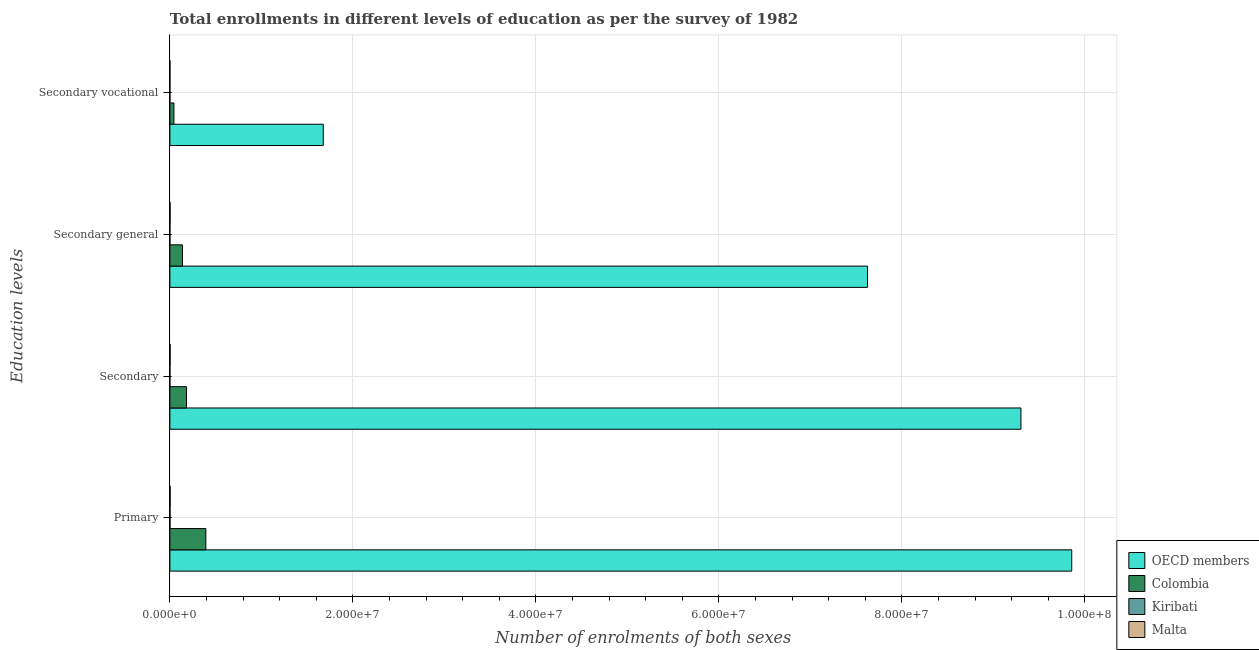How many different coloured bars are there?
Give a very brief answer. 4. Are the number of bars on each tick of the Y-axis equal?
Keep it short and to the point. Yes. How many bars are there on the 3rd tick from the top?
Your answer should be compact. 4. What is the label of the 3rd group of bars from the top?
Ensure brevity in your answer.  Secondary. What is the number of enrolments in primary education in Malta?
Give a very brief answer. 3.32e+04. Across all countries, what is the maximum number of enrolments in secondary education?
Provide a succinct answer. 9.30e+07. Across all countries, what is the minimum number of enrolments in secondary vocational education?
Make the answer very short. 946. In which country was the number of enrolments in secondary education maximum?
Ensure brevity in your answer.  OECD members. In which country was the number of enrolments in primary education minimum?
Make the answer very short. Kiribati. What is the total number of enrolments in secondary vocational education in the graph?
Make the answer very short. 1.72e+07. What is the difference between the number of enrolments in primary education in Kiribati and that in Malta?
Your answer should be very brief. -1.94e+04. What is the difference between the number of enrolments in primary education in Malta and the number of enrolments in secondary education in Kiribati?
Offer a terse response. 3.13e+04. What is the average number of enrolments in primary education per country?
Your answer should be very brief. 2.56e+07. What is the difference between the number of enrolments in secondary vocational education and number of enrolments in secondary general education in Malta?
Keep it short and to the point. -1.75e+04. In how many countries, is the number of enrolments in primary education greater than 64000000 ?
Ensure brevity in your answer.  1. What is the ratio of the number of enrolments in secondary education in Malta to that in Colombia?
Keep it short and to the point. 0.01. What is the difference between the highest and the second highest number of enrolments in secondary education?
Keep it short and to the point. 9.12e+07. What is the difference between the highest and the lowest number of enrolments in primary education?
Your response must be concise. 9.85e+07. In how many countries, is the number of enrolments in primary education greater than the average number of enrolments in primary education taken over all countries?
Make the answer very short. 1. Is it the case that in every country, the sum of the number of enrolments in primary education and number of enrolments in secondary general education is greater than the sum of number of enrolments in secondary vocational education and number of enrolments in secondary education?
Your answer should be compact. No. What does the 3rd bar from the top in Secondary vocational represents?
Offer a terse response. Colombia. How many bars are there?
Keep it short and to the point. 16. How many countries are there in the graph?
Offer a very short reply. 4. Are the values on the major ticks of X-axis written in scientific E-notation?
Make the answer very short. Yes. Does the graph contain grids?
Your answer should be very brief. Yes. How many legend labels are there?
Provide a short and direct response. 4. How are the legend labels stacked?
Give a very brief answer. Vertical. What is the title of the graph?
Your answer should be very brief. Total enrollments in different levels of education as per the survey of 1982. Does "Maldives" appear as one of the legend labels in the graph?
Make the answer very short. No. What is the label or title of the X-axis?
Provide a short and direct response. Number of enrolments of both sexes. What is the label or title of the Y-axis?
Provide a short and direct response. Education levels. What is the Number of enrolments of both sexes in OECD members in Primary?
Your answer should be compact. 9.86e+07. What is the Number of enrolments of both sexes of Colombia in Primary?
Make the answer very short. 3.93e+06. What is the Number of enrolments of both sexes of Kiribati in Primary?
Ensure brevity in your answer.  1.38e+04. What is the Number of enrolments of both sexes of Malta in Primary?
Your answer should be compact. 3.32e+04. What is the Number of enrolments of both sexes in OECD members in Secondary?
Provide a short and direct response. 9.30e+07. What is the Number of enrolments of both sexes of Colombia in Secondary?
Provide a succinct answer. 1.82e+06. What is the Number of enrolments of both sexes of Kiribati in Secondary?
Your answer should be compact. 1896. What is the Number of enrolments of both sexes of Malta in Secondary?
Provide a short and direct response. 2.67e+04. What is the Number of enrolments of both sexes in OECD members in Secondary general?
Your response must be concise. 7.62e+07. What is the Number of enrolments of both sexes in Colombia in Secondary general?
Give a very brief answer. 1.37e+06. What is the Number of enrolments of both sexes in Kiribati in Secondary general?
Make the answer very short. 950. What is the Number of enrolments of both sexes of Malta in Secondary general?
Offer a very short reply. 2.21e+04. What is the Number of enrolments of both sexes in OECD members in Secondary vocational?
Offer a terse response. 1.68e+07. What is the Number of enrolments of both sexes of Colombia in Secondary vocational?
Your answer should be very brief. 4.42e+05. What is the Number of enrolments of both sexes in Kiribati in Secondary vocational?
Ensure brevity in your answer.  946. What is the Number of enrolments of both sexes of Malta in Secondary vocational?
Give a very brief answer. 4623. Across all Education levels, what is the maximum Number of enrolments of both sexes of OECD members?
Your answer should be compact. 9.86e+07. Across all Education levels, what is the maximum Number of enrolments of both sexes of Colombia?
Offer a terse response. 3.93e+06. Across all Education levels, what is the maximum Number of enrolments of both sexes of Kiribati?
Your answer should be compact. 1.38e+04. Across all Education levels, what is the maximum Number of enrolments of both sexes in Malta?
Provide a succinct answer. 3.32e+04. Across all Education levels, what is the minimum Number of enrolments of both sexes of OECD members?
Provide a short and direct response. 1.68e+07. Across all Education levels, what is the minimum Number of enrolments of both sexes in Colombia?
Ensure brevity in your answer.  4.42e+05. Across all Education levels, what is the minimum Number of enrolments of both sexes in Kiribati?
Your answer should be very brief. 946. Across all Education levels, what is the minimum Number of enrolments of both sexes in Malta?
Ensure brevity in your answer.  4623. What is the total Number of enrolments of both sexes in OECD members in the graph?
Provide a short and direct response. 2.85e+08. What is the total Number of enrolments of both sexes in Colombia in the graph?
Offer a terse response. 7.56e+06. What is the total Number of enrolments of both sexes of Kiribati in the graph?
Your answer should be compact. 1.76e+04. What is the total Number of enrolments of both sexes of Malta in the graph?
Your answer should be compact. 8.66e+04. What is the difference between the Number of enrolments of both sexes in OECD members in Primary and that in Secondary?
Your answer should be very brief. 5.55e+06. What is the difference between the Number of enrolments of both sexes of Colombia in Primary and that in Secondary?
Offer a terse response. 2.11e+06. What is the difference between the Number of enrolments of both sexes in Kiribati in Primary and that in Secondary?
Provide a short and direct response. 1.19e+04. What is the difference between the Number of enrolments of both sexes in Malta in Primary and that in Secondary?
Your response must be concise. 6487. What is the difference between the Number of enrolments of both sexes in OECD members in Primary and that in Secondary general?
Provide a short and direct response. 2.23e+07. What is the difference between the Number of enrolments of both sexes in Colombia in Primary and that in Secondary general?
Ensure brevity in your answer.  2.56e+06. What is the difference between the Number of enrolments of both sexes in Kiribati in Primary and that in Secondary general?
Make the answer very short. 1.29e+04. What is the difference between the Number of enrolments of both sexes in Malta in Primary and that in Secondary general?
Keep it short and to the point. 1.11e+04. What is the difference between the Number of enrolments of both sexes in OECD members in Primary and that in Secondary vocational?
Your response must be concise. 8.18e+07. What is the difference between the Number of enrolments of both sexes in Colombia in Primary and that in Secondary vocational?
Offer a very short reply. 3.49e+06. What is the difference between the Number of enrolments of both sexes in Kiribati in Primary and that in Secondary vocational?
Give a very brief answer. 1.29e+04. What is the difference between the Number of enrolments of both sexes of Malta in Primary and that in Secondary vocational?
Your answer should be very brief. 2.86e+04. What is the difference between the Number of enrolments of both sexes of OECD members in Secondary and that in Secondary general?
Offer a very short reply. 1.68e+07. What is the difference between the Number of enrolments of both sexes in Colombia in Secondary and that in Secondary general?
Keep it short and to the point. 4.42e+05. What is the difference between the Number of enrolments of both sexes in Kiribati in Secondary and that in Secondary general?
Your answer should be compact. 946. What is the difference between the Number of enrolments of both sexes of Malta in Secondary and that in Secondary general?
Your response must be concise. 4623. What is the difference between the Number of enrolments of both sexes of OECD members in Secondary and that in Secondary vocational?
Keep it short and to the point. 7.62e+07. What is the difference between the Number of enrolments of both sexes of Colombia in Secondary and that in Secondary vocational?
Ensure brevity in your answer.  1.37e+06. What is the difference between the Number of enrolments of both sexes in Kiribati in Secondary and that in Secondary vocational?
Your response must be concise. 950. What is the difference between the Number of enrolments of both sexes of Malta in Secondary and that in Secondary vocational?
Your answer should be compact. 2.21e+04. What is the difference between the Number of enrolments of both sexes of OECD members in Secondary general and that in Secondary vocational?
Your response must be concise. 5.95e+07. What is the difference between the Number of enrolments of both sexes of Colombia in Secondary general and that in Secondary vocational?
Ensure brevity in your answer.  9.33e+05. What is the difference between the Number of enrolments of both sexes of Malta in Secondary general and that in Secondary vocational?
Your response must be concise. 1.75e+04. What is the difference between the Number of enrolments of both sexes in OECD members in Primary and the Number of enrolments of both sexes in Colombia in Secondary?
Your response must be concise. 9.67e+07. What is the difference between the Number of enrolments of both sexes in OECD members in Primary and the Number of enrolments of both sexes in Kiribati in Secondary?
Your answer should be compact. 9.86e+07. What is the difference between the Number of enrolments of both sexes of OECD members in Primary and the Number of enrolments of both sexes of Malta in Secondary?
Offer a terse response. 9.85e+07. What is the difference between the Number of enrolments of both sexes of Colombia in Primary and the Number of enrolments of both sexes of Kiribati in Secondary?
Your response must be concise. 3.93e+06. What is the difference between the Number of enrolments of both sexes of Colombia in Primary and the Number of enrolments of both sexes of Malta in Secondary?
Provide a short and direct response. 3.90e+06. What is the difference between the Number of enrolments of both sexes in Kiribati in Primary and the Number of enrolments of both sexes in Malta in Secondary?
Provide a short and direct response. -1.29e+04. What is the difference between the Number of enrolments of both sexes of OECD members in Primary and the Number of enrolments of both sexes of Colombia in Secondary general?
Give a very brief answer. 9.72e+07. What is the difference between the Number of enrolments of both sexes in OECD members in Primary and the Number of enrolments of both sexes in Kiribati in Secondary general?
Keep it short and to the point. 9.86e+07. What is the difference between the Number of enrolments of both sexes in OECD members in Primary and the Number of enrolments of both sexes in Malta in Secondary general?
Your answer should be compact. 9.85e+07. What is the difference between the Number of enrolments of both sexes in Colombia in Primary and the Number of enrolments of both sexes in Kiribati in Secondary general?
Your response must be concise. 3.93e+06. What is the difference between the Number of enrolments of both sexes of Colombia in Primary and the Number of enrolments of both sexes of Malta in Secondary general?
Give a very brief answer. 3.91e+06. What is the difference between the Number of enrolments of both sexes in Kiribati in Primary and the Number of enrolments of both sexes in Malta in Secondary general?
Your response must be concise. -8241. What is the difference between the Number of enrolments of both sexes of OECD members in Primary and the Number of enrolments of both sexes of Colombia in Secondary vocational?
Give a very brief answer. 9.81e+07. What is the difference between the Number of enrolments of both sexes in OECD members in Primary and the Number of enrolments of both sexes in Kiribati in Secondary vocational?
Your answer should be very brief. 9.86e+07. What is the difference between the Number of enrolments of both sexes of OECD members in Primary and the Number of enrolments of both sexes of Malta in Secondary vocational?
Your answer should be very brief. 9.86e+07. What is the difference between the Number of enrolments of both sexes of Colombia in Primary and the Number of enrolments of both sexes of Kiribati in Secondary vocational?
Your response must be concise. 3.93e+06. What is the difference between the Number of enrolments of both sexes in Colombia in Primary and the Number of enrolments of both sexes in Malta in Secondary vocational?
Your response must be concise. 3.93e+06. What is the difference between the Number of enrolments of both sexes of Kiribati in Primary and the Number of enrolments of both sexes of Malta in Secondary vocational?
Your answer should be compact. 9213. What is the difference between the Number of enrolments of both sexes of OECD members in Secondary and the Number of enrolments of both sexes of Colombia in Secondary general?
Offer a terse response. 9.16e+07. What is the difference between the Number of enrolments of both sexes in OECD members in Secondary and the Number of enrolments of both sexes in Kiribati in Secondary general?
Ensure brevity in your answer.  9.30e+07. What is the difference between the Number of enrolments of both sexes of OECD members in Secondary and the Number of enrolments of both sexes of Malta in Secondary general?
Offer a very short reply. 9.30e+07. What is the difference between the Number of enrolments of both sexes in Colombia in Secondary and the Number of enrolments of both sexes in Kiribati in Secondary general?
Your answer should be compact. 1.82e+06. What is the difference between the Number of enrolments of both sexes of Colombia in Secondary and the Number of enrolments of both sexes of Malta in Secondary general?
Your response must be concise. 1.79e+06. What is the difference between the Number of enrolments of both sexes of Kiribati in Secondary and the Number of enrolments of both sexes of Malta in Secondary general?
Provide a succinct answer. -2.02e+04. What is the difference between the Number of enrolments of both sexes in OECD members in Secondary and the Number of enrolments of both sexes in Colombia in Secondary vocational?
Offer a terse response. 9.26e+07. What is the difference between the Number of enrolments of both sexes in OECD members in Secondary and the Number of enrolments of both sexes in Kiribati in Secondary vocational?
Make the answer very short. 9.30e+07. What is the difference between the Number of enrolments of both sexes in OECD members in Secondary and the Number of enrolments of both sexes in Malta in Secondary vocational?
Your response must be concise. 9.30e+07. What is the difference between the Number of enrolments of both sexes in Colombia in Secondary and the Number of enrolments of both sexes in Kiribati in Secondary vocational?
Provide a short and direct response. 1.82e+06. What is the difference between the Number of enrolments of both sexes in Colombia in Secondary and the Number of enrolments of both sexes in Malta in Secondary vocational?
Ensure brevity in your answer.  1.81e+06. What is the difference between the Number of enrolments of both sexes in Kiribati in Secondary and the Number of enrolments of both sexes in Malta in Secondary vocational?
Ensure brevity in your answer.  -2727. What is the difference between the Number of enrolments of both sexes of OECD members in Secondary general and the Number of enrolments of both sexes of Colombia in Secondary vocational?
Ensure brevity in your answer.  7.58e+07. What is the difference between the Number of enrolments of both sexes in OECD members in Secondary general and the Number of enrolments of both sexes in Kiribati in Secondary vocational?
Provide a succinct answer. 7.62e+07. What is the difference between the Number of enrolments of both sexes in OECD members in Secondary general and the Number of enrolments of both sexes in Malta in Secondary vocational?
Give a very brief answer. 7.62e+07. What is the difference between the Number of enrolments of both sexes in Colombia in Secondary general and the Number of enrolments of both sexes in Kiribati in Secondary vocational?
Provide a succinct answer. 1.37e+06. What is the difference between the Number of enrolments of both sexes in Colombia in Secondary general and the Number of enrolments of both sexes in Malta in Secondary vocational?
Offer a very short reply. 1.37e+06. What is the difference between the Number of enrolments of both sexes in Kiribati in Secondary general and the Number of enrolments of both sexes in Malta in Secondary vocational?
Keep it short and to the point. -3673. What is the average Number of enrolments of both sexes of OECD members per Education levels?
Your answer should be compact. 7.11e+07. What is the average Number of enrolments of both sexes in Colombia per Education levels?
Make the answer very short. 1.89e+06. What is the average Number of enrolments of both sexes in Kiribati per Education levels?
Ensure brevity in your answer.  4407. What is the average Number of enrolments of both sexes of Malta per Education levels?
Offer a very short reply. 2.16e+04. What is the difference between the Number of enrolments of both sexes of OECD members and Number of enrolments of both sexes of Colombia in Primary?
Keep it short and to the point. 9.46e+07. What is the difference between the Number of enrolments of both sexes of OECD members and Number of enrolments of both sexes of Kiribati in Primary?
Keep it short and to the point. 9.85e+07. What is the difference between the Number of enrolments of both sexes of OECD members and Number of enrolments of both sexes of Malta in Primary?
Make the answer very short. 9.85e+07. What is the difference between the Number of enrolments of both sexes in Colombia and Number of enrolments of both sexes in Kiribati in Primary?
Keep it short and to the point. 3.92e+06. What is the difference between the Number of enrolments of both sexes of Colombia and Number of enrolments of both sexes of Malta in Primary?
Offer a terse response. 3.90e+06. What is the difference between the Number of enrolments of both sexes of Kiribati and Number of enrolments of both sexes of Malta in Primary?
Provide a succinct answer. -1.94e+04. What is the difference between the Number of enrolments of both sexes of OECD members and Number of enrolments of both sexes of Colombia in Secondary?
Provide a short and direct response. 9.12e+07. What is the difference between the Number of enrolments of both sexes in OECD members and Number of enrolments of both sexes in Kiribati in Secondary?
Your response must be concise. 9.30e+07. What is the difference between the Number of enrolments of both sexes in OECD members and Number of enrolments of both sexes in Malta in Secondary?
Your answer should be very brief. 9.30e+07. What is the difference between the Number of enrolments of both sexes of Colombia and Number of enrolments of both sexes of Kiribati in Secondary?
Offer a very short reply. 1.81e+06. What is the difference between the Number of enrolments of both sexes in Colombia and Number of enrolments of both sexes in Malta in Secondary?
Offer a very short reply. 1.79e+06. What is the difference between the Number of enrolments of both sexes in Kiribati and Number of enrolments of both sexes in Malta in Secondary?
Offer a very short reply. -2.48e+04. What is the difference between the Number of enrolments of both sexes of OECD members and Number of enrolments of both sexes of Colombia in Secondary general?
Provide a succinct answer. 7.49e+07. What is the difference between the Number of enrolments of both sexes of OECD members and Number of enrolments of both sexes of Kiribati in Secondary general?
Your answer should be compact. 7.62e+07. What is the difference between the Number of enrolments of both sexes of OECD members and Number of enrolments of both sexes of Malta in Secondary general?
Your answer should be very brief. 7.62e+07. What is the difference between the Number of enrolments of both sexes of Colombia and Number of enrolments of both sexes of Kiribati in Secondary general?
Your response must be concise. 1.37e+06. What is the difference between the Number of enrolments of both sexes of Colombia and Number of enrolments of both sexes of Malta in Secondary general?
Give a very brief answer. 1.35e+06. What is the difference between the Number of enrolments of both sexes in Kiribati and Number of enrolments of both sexes in Malta in Secondary general?
Give a very brief answer. -2.11e+04. What is the difference between the Number of enrolments of both sexes of OECD members and Number of enrolments of both sexes of Colombia in Secondary vocational?
Offer a terse response. 1.63e+07. What is the difference between the Number of enrolments of both sexes in OECD members and Number of enrolments of both sexes in Kiribati in Secondary vocational?
Provide a short and direct response. 1.68e+07. What is the difference between the Number of enrolments of both sexes in OECD members and Number of enrolments of both sexes in Malta in Secondary vocational?
Ensure brevity in your answer.  1.68e+07. What is the difference between the Number of enrolments of both sexes in Colombia and Number of enrolments of both sexes in Kiribati in Secondary vocational?
Your answer should be very brief. 4.41e+05. What is the difference between the Number of enrolments of both sexes in Colombia and Number of enrolments of both sexes in Malta in Secondary vocational?
Ensure brevity in your answer.  4.37e+05. What is the difference between the Number of enrolments of both sexes in Kiribati and Number of enrolments of both sexes in Malta in Secondary vocational?
Offer a very short reply. -3677. What is the ratio of the Number of enrolments of both sexes of OECD members in Primary to that in Secondary?
Provide a succinct answer. 1.06. What is the ratio of the Number of enrolments of both sexes of Colombia in Primary to that in Secondary?
Give a very brief answer. 2.16. What is the ratio of the Number of enrolments of both sexes in Kiribati in Primary to that in Secondary?
Your response must be concise. 7.3. What is the ratio of the Number of enrolments of both sexes of Malta in Primary to that in Secondary?
Give a very brief answer. 1.24. What is the ratio of the Number of enrolments of both sexes in OECD members in Primary to that in Secondary general?
Provide a succinct answer. 1.29. What is the ratio of the Number of enrolments of both sexes in Colombia in Primary to that in Secondary general?
Ensure brevity in your answer.  2.86. What is the ratio of the Number of enrolments of both sexes of Kiribati in Primary to that in Secondary general?
Make the answer very short. 14.56. What is the ratio of the Number of enrolments of both sexes in Malta in Primary to that in Secondary general?
Your answer should be very brief. 1.5. What is the ratio of the Number of enrolments of both sexes of OECD members in Primary to that in Secondary vocational?
Offer a very short reply. 5.88. What is the ratio of the Number of enrolments of both sexes of Colombia in Primary to that in Secondary vocational?
Give a very brief answer. 8.89. What is the ratio of the Number of enrolments of both sexes of Kiribati in Primary to that in Secondary vocational?
Ensure brevity in your answer.  14.63. What is the ratio of the Number of enrolments of both sexes of Malta in Primary to that in Secondary vocational?
Give a very brief answer. 7.18. What is the ratio of the Number of enrolments of both sexes in OECD members in Secondary to that in Secondary general?
Your response must be concise. 1.22. What is the ratio of the Number of enrolments of both sexes of Colombia in Secondary to that in Secondary general?
Keep it short and to the point. 1.32. What is the ratio of the Number of enrolments of both sexes of Kiribati in Secondary to that in Secondary general?
Make the answer very short. 2. What is the ratio of the Number of enrolments of both sexes of Malta in Secondary to that in Secondary general?
Offer a very short reply. 1.21. What is the ratio of the Number of enrolments of both sexes of OECD members in Secondary to that in Secondary vocational?
Give a very brief answer. 5.55. What is the ratio of the Number of enrolments of both sexes of Colombia in Secondary to that in Secondary vocational?
Ensure brevity in your answer.  4.11. What is the ratio of the Number of enrolments of both sexes in Kiribati in Secondary to that in Secondary vocational?
Give a very brief answer. 2. What is the ratio of the Number of enrolments of both sexes in Malta in Secondary to that in Secondary vocational?
Offer a very short reply. 5.78. What is the ratio of the Number of enrolments of both sexes in OECD members in Secondary general to that in Secondary vocational?
Give a very brief answer. 4.55. What is the ratio of the Number of enrolments of both sexes of Colombia in Secondary general to that in Secondary vocational?
Offer a very short reply. 3.11. What is the ratio of the Number of enrolments of both sexes in Malta in Secondary general to that in Secondary vocational?
Give a very brief answer. 4.78. What is the difference between the highest and the second highest Number of enrolments of both sexes in OECD members?
Your answer should be very brief. 5.55e+06. What is the difference between the highest and the second highest Number of enrolments of both sexes in Colombia?
Ensure brevity in your answer.  2.11e+06. What is the difference between the highest and the second highest Number of enrolments of both sexes in Kiribati?
Ensure brevity in your answer.  1.19e+04. What is the difference between the highest and the second highest Number of enrolments of both sexes of Malta?
Keep it short and to the point. 6487. What is the difference between the highest and the lowest Number of enrolments of both sexes in OECD members?
Provide a succinct answer. 8.18e+07. What is the difference between the highest and the lowest Number of enrolments of both sexes of Colombia?
Provide a short and direct response. 3.49e+06. What is the difference between the highest and the lowest Number of enrolments of both sexes of Kiribati?
Offer a terse response. 1.29e+04. What is the difference between the highest and the lowest Number of enrolments of both sexes in Malta?
Offer a very short reply. 2.86e+04. 